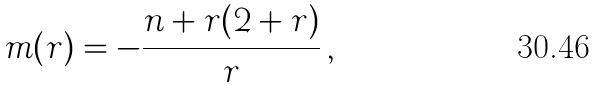Convert formula to latex. <formula><loc_0><loc_0><loc_500><loc_500>m ( r ) = - \frac { n + r ( 2 + r ) } { r } \, ,</formula> 